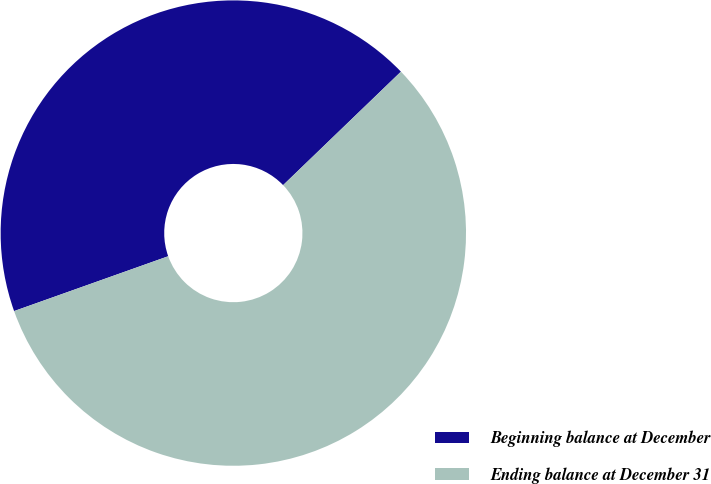Convert chart to OTSL. <chart><loc_0><loc_0><loc_500><loc_500><pie_chart><fcel>Beginning balance at December<fcel>Ending balance at December 31<nl><fcel>43.24%<fcel>56.76%<nl></chart> 